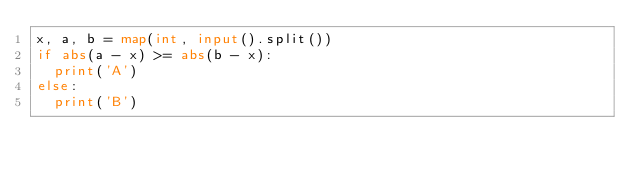<code> <loc_0><loc_0><loc_500><loc_500><_Python_>x, a, b = map(int, input().split())
if abs(a - x) >= abs(b - x):
  print('A')
else:
  print('B')</code> 